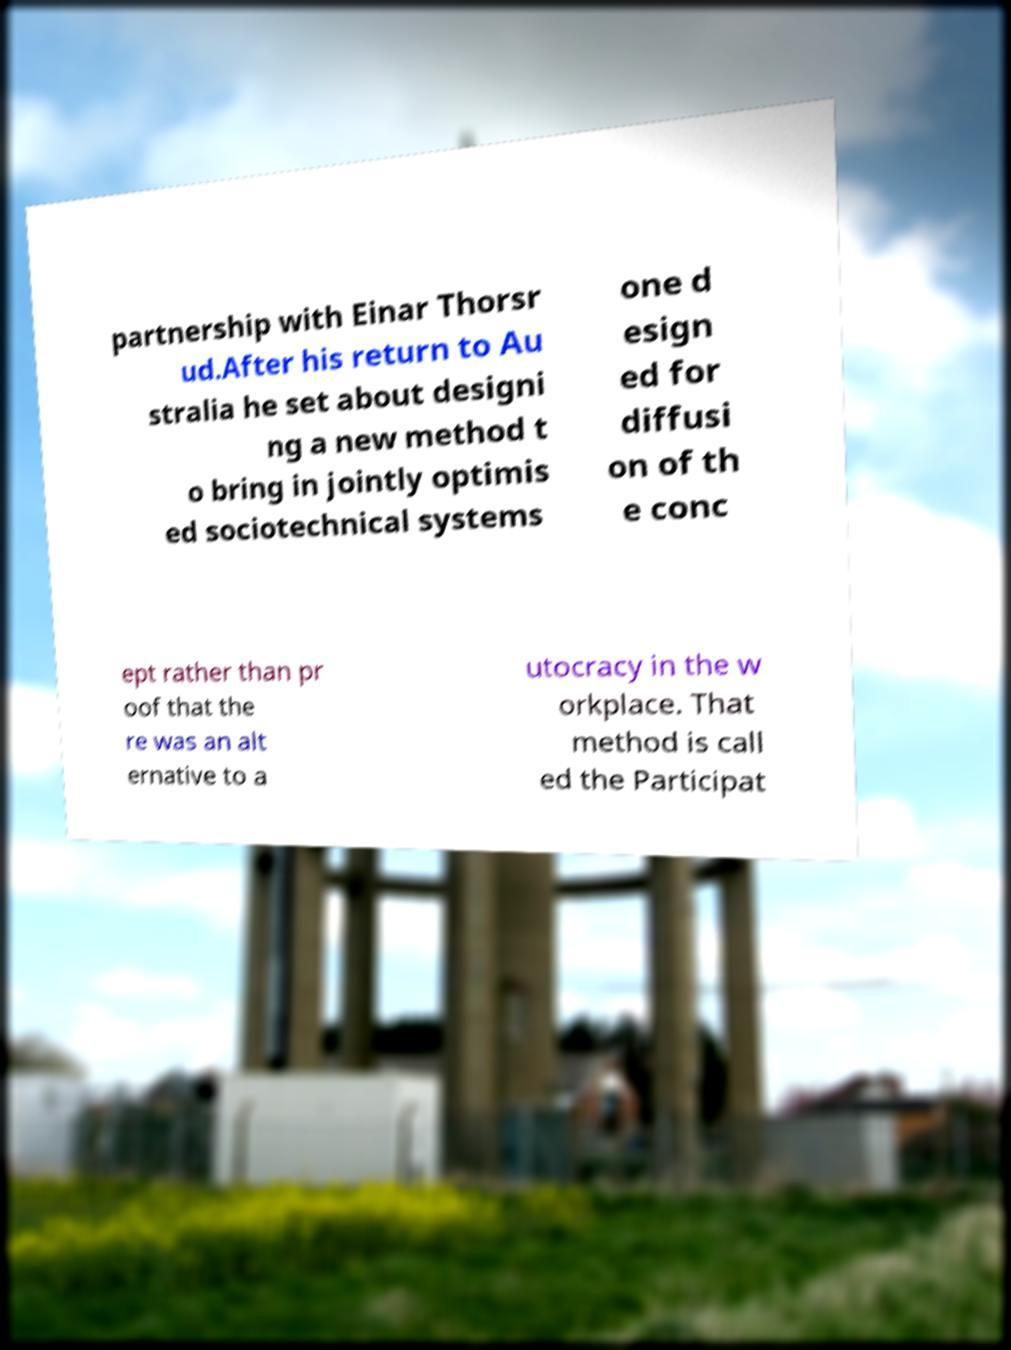Please identify and transcribe the text found in this image. partnership with Einar Thorsr ud.After his return to Au stralia he set about designi ng a new method t o bring in jointly optimis ed sociotechnical systems one d esign ed for diffusi on of th e conc ept rather than pr oof that the re was an alt ernative to a utocracy in the w orkplace. That method is call ed the Participat 